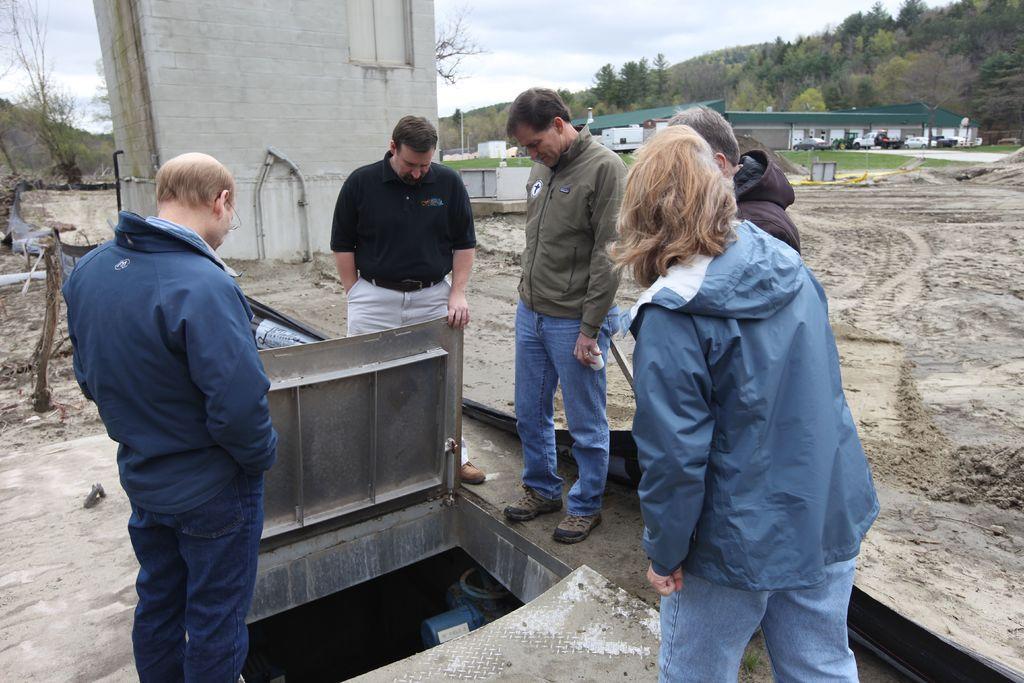Can you describe this image briefly? This image is taken outdoors. At the bottom of the image there is a ground and there is a tank covered with iron sheets. In the background there are a few hills, trees and plants and there are a few houses and a few vehicles are parked on the ground. At the top of the image there is a sky with clouds. In the middle of the image there is a building and a few people are standing on the ground. 